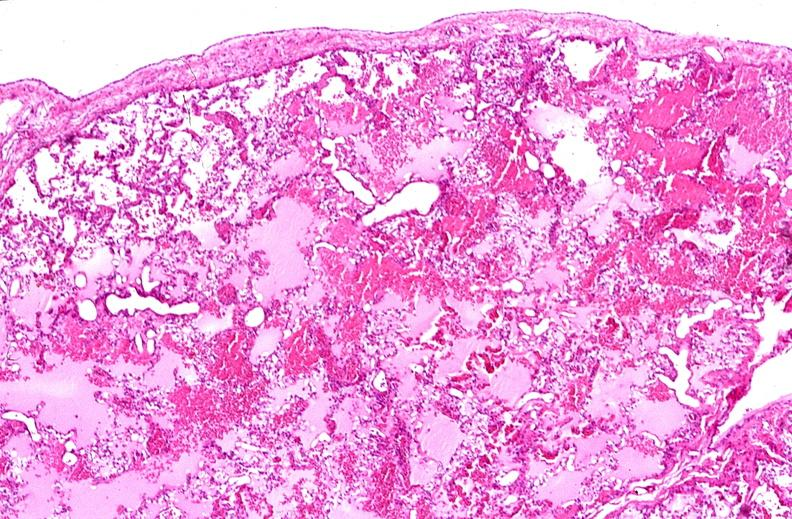does this image show lung, pulmonary edema in patient with congestive heart failure due to heart transplant rejection?
Answer the question using a single word or phrase. Yes 